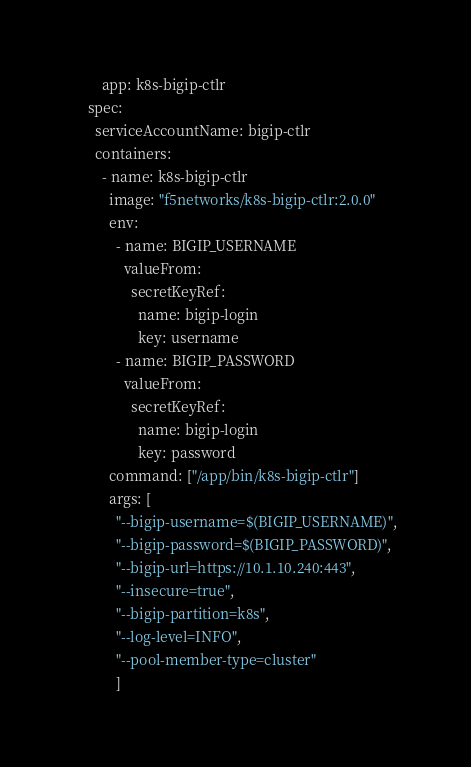Convert code to text. <code><loc_0><loc_0><loc_500><loc_500><_YAML_>        app: k8s-bigip-ctlr
    spec:
      serviceAccountName: bigip-ctlr
      containers:
        - name: k8s-bigip-ctlr
          image: "f5networks/k8s-bigip-ctlr:2.0.0"
          env:
            - name: BIGIP_USERNAME
              valueFrom:
                secretKeyRef:
                  name: bigip-login
                  key: username
            - name: BIGIP_PASSWORD
              valueFrom:
                secretKeyRef:
                  name: bigip-login
                  key: password
          command: ["/app/bin/k8s-bigip-ctlr"]
          args: [
            "--bigip-username=$(BIGIP_USERNAME)",
            "--bigip-password=$(BIGIP_PASSWORD)",
            "--bigip-url=https://10.1.10.240:443",
            "--insecure=true",
            "--bigip-partition=k8s",
            "--log-level=INFO",
            "--pool-member-type=cluster"
            ]
</code> 